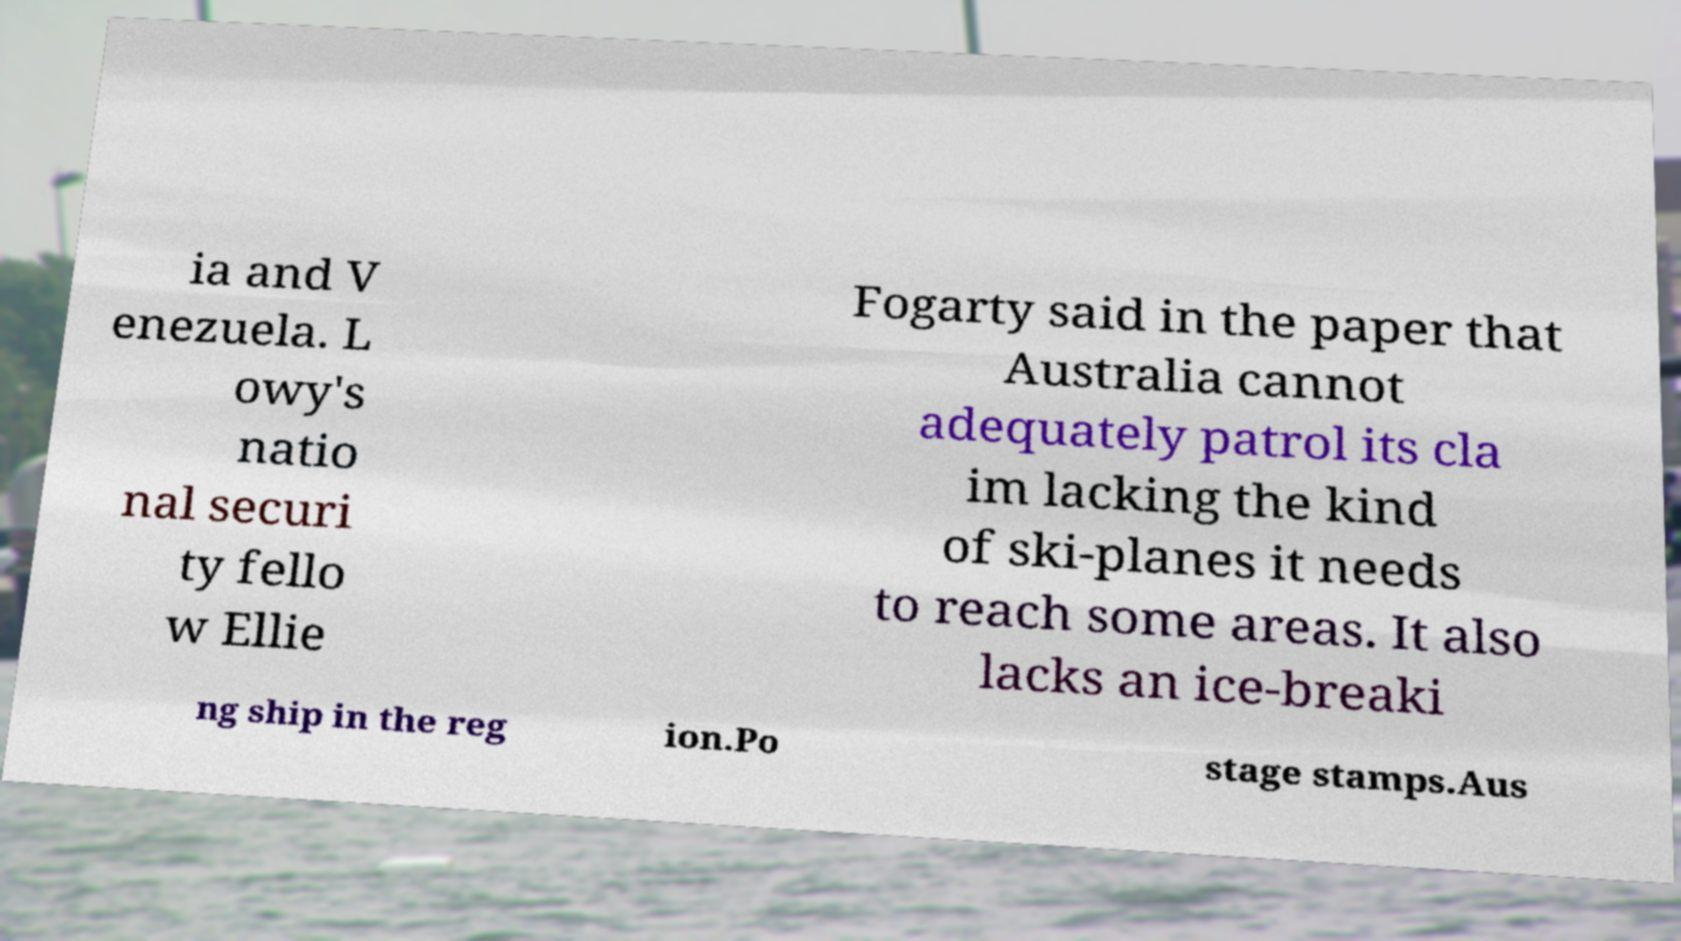What messages or text are displayed in this image? I need them in a readable, typed format. ia and V enezuela. L owy's natio nal securi ty fello w Ellie Fogarty said in the paper that Australia cannot adequately patrol its cla im lacking the kind of ski-planes it needs to reach some areas. It also lacks an ice-breaki ng ship in the reg ion.Po stage stamps.Aus 